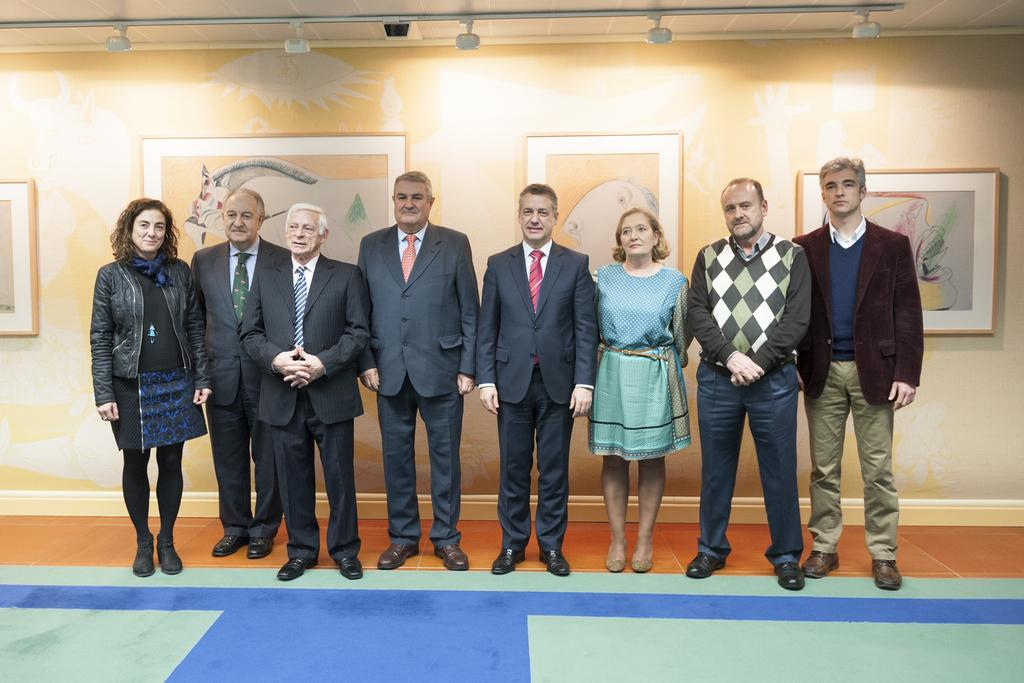What can be seen in the image regarding the people? There are people standing in the image. Where are the people standing? The people are standing on the floor. What can be seen in the image regarding the lighting? There are ceiling lights visible in the image. What is above the people in the image? There is a roof in the image. What is on the wall in the image? There are photo frames on the wall. What is the queen's reaction to the stranger in the image? There is no queen or stranger present in the image. 